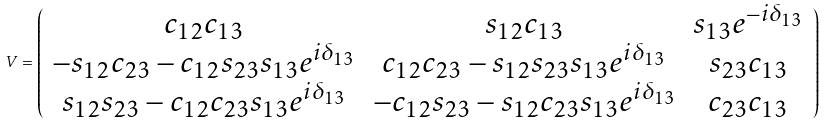Convert formula to latex. <formula><loc_0><loc_0><loc_500><loc_500>V = \left ( \begin{array} { c c c } c _ { 1 2 } c _ { 1 3 } & s _ { 1 2 } c _ { 1 3 } & s _ { 1 3 } e ^ { - i \delta _ { 1 3 } } \\ - s _ { 1 2 } c _ { 2 3 } - c _ { 1 2 } s _ { 2 3 } s _ { 1 3 } e ^ { i \delta _ { 1 3 } } & c _ { 1 2 } c _ { 2 3 } - s _ { 1 2 } s _ { 2 3 } s _ { 1 3 } e ^ { i \delta _ { 1 3 } } & s _ { 2 3 } c _ { 1 3 } \\ s _ { 1 2 } s _ { 2 3 } - c _ { 1 2 } c _ { 2 3 } s _ { 1 3 } e ^ { i \delta _ { 1 3 } } & - c _ { 1 2 } s _ { 2 3 } - s _ { 1 2 } c _ { 2 3 } s _ { 1 3 } e ^ { i \delta _ { 1 3 } } & c _ { 2 3 } c _ { 1 3 } \end{array} \right )</formula> 